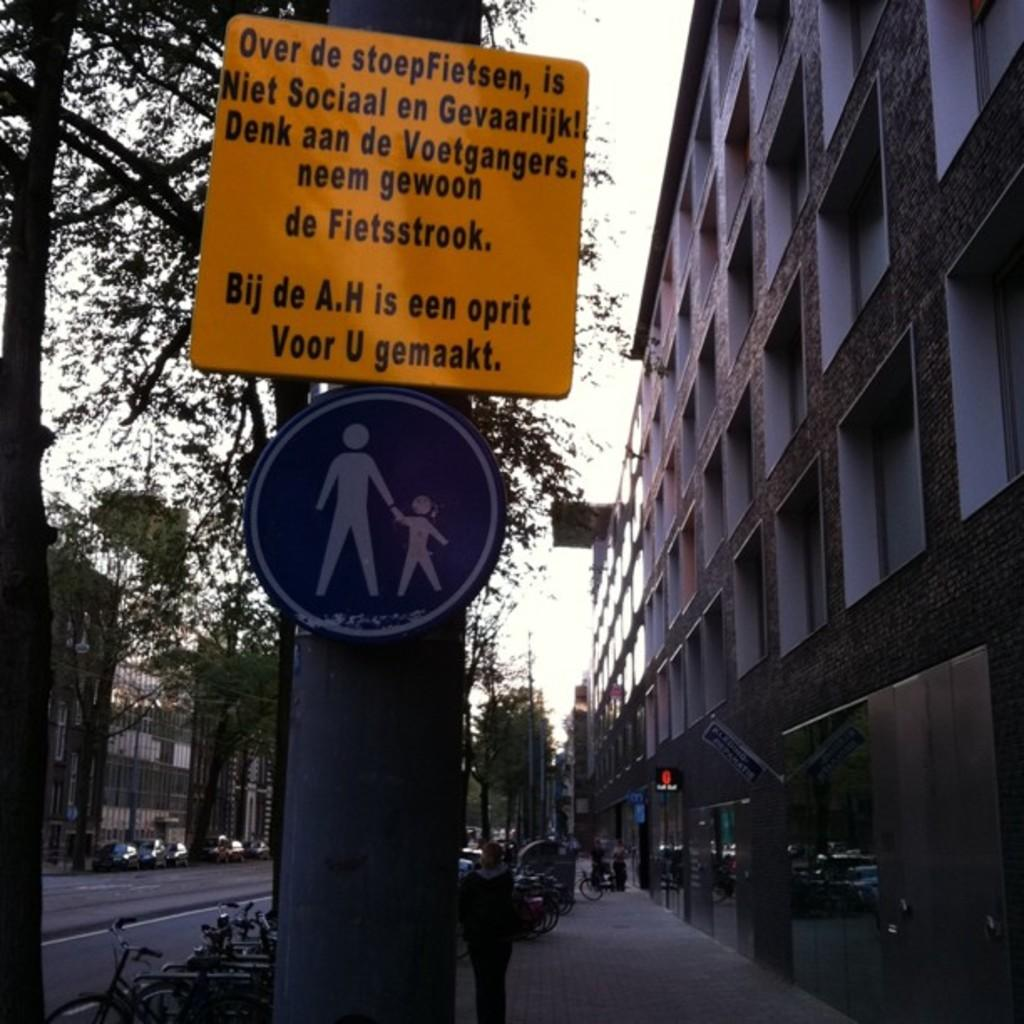Provide a one-sentence caption for the provided image. The orange sign is in a foreign language but it warns, "is Niet Sociaal en Gevaarlijk!". 